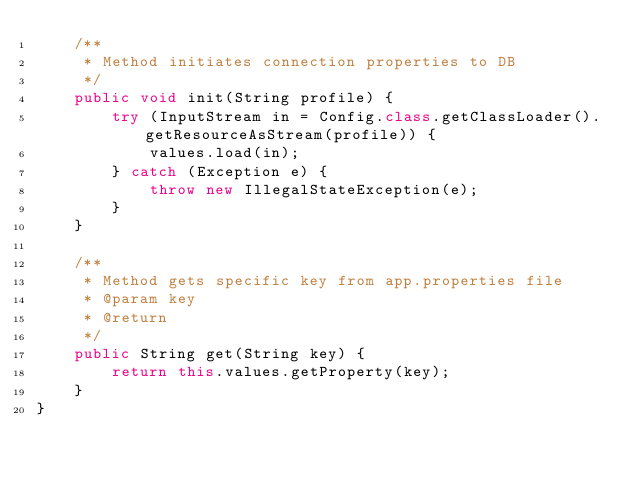Convert code to text. <code><loc_0><loc_0><loc_500><loc_500><_Java_>    /**
     * Method initiates connection properties to DB
     */
    public void init(String profile) {
        try (InputStream in = Config.class.getClassLoader().getResourceAsStream(profile)) {
            values.load(in);
        } catch (Exception e) {
            throw new IllegalStateException(e);
        }
    }

    /**
     * Method gets specific key from app.properties file
     * @param key
     * @return
     */
    public String get(String key) {
        return this.values.getProperty(key);
    }
}
</code> 